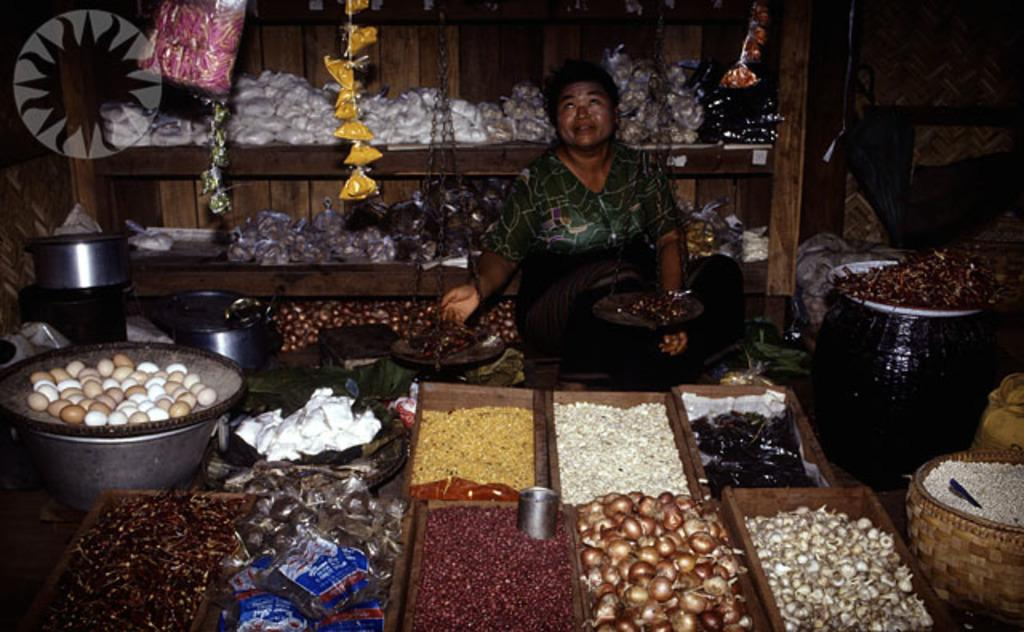What is the person in the image doing? There is a person sitting in the image. What type of food items can be seen in the image? There are vegetables and onions in the image. What other objects are present in the image besides the vegetables and onions? There are other objects in the image. What can be seen in the background of the image? There is a wooden shelf in the background of the image. What is on the wooden shelf? The wooden shelf has objects on it. What type of zebra can be seen on the wooden shelf in the image? There is no zebra present in the image, and therefore none can be seen on the wooden shelf. How many bells are hanging from the person's neck in the image? There are no bells visible in the image, and the person is not wearing any. 